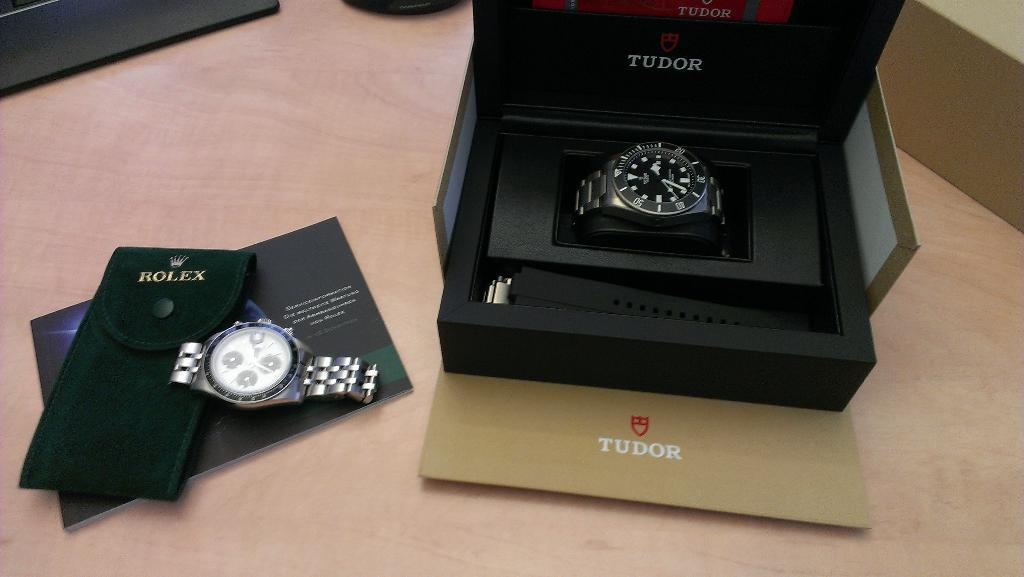<image>
Create a compact narrative representing the image presented. Black watch in a box which says TUDOR on it. 